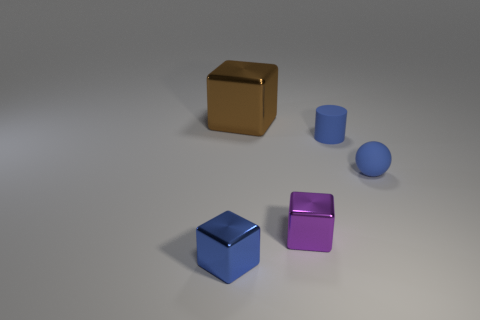Are there the same number of tiny spheres that are to the left of the small cylinder and large red metal cylinders?
Provide a succinct answer. Yes. Is the blue rubber ball the same size as the brown object?
Your answer should be very brief. No. What material is the object that is behind the ball and on the right side of the purple object?
Offer a very short reply. Rubber. How many small blue objects have the same shape as the brown shiny object?
Your answer should be very brief. 1. There is a tiny cylinder that is in front of the brown cube; what is it made of?
Provide a short and direct response. Rubber. Is the number of small blue things on the left side of the tiny matte ball less than the number of small rubber cylinders?
Offer a very short reply. No. Is the shape of the big metallic thing the same as the blue shiny thing?
Your answer should be very brief. Yes. Is there anything else that is the same shape as the large brown thing?
Make the answer very short. Yes. Is there a large green metal ball?
Offer a terse response. No. Does the tiny purple object have the same shape as the metal thing on the left side of the large brown cube?
Provide a succinct answer. Yes. 